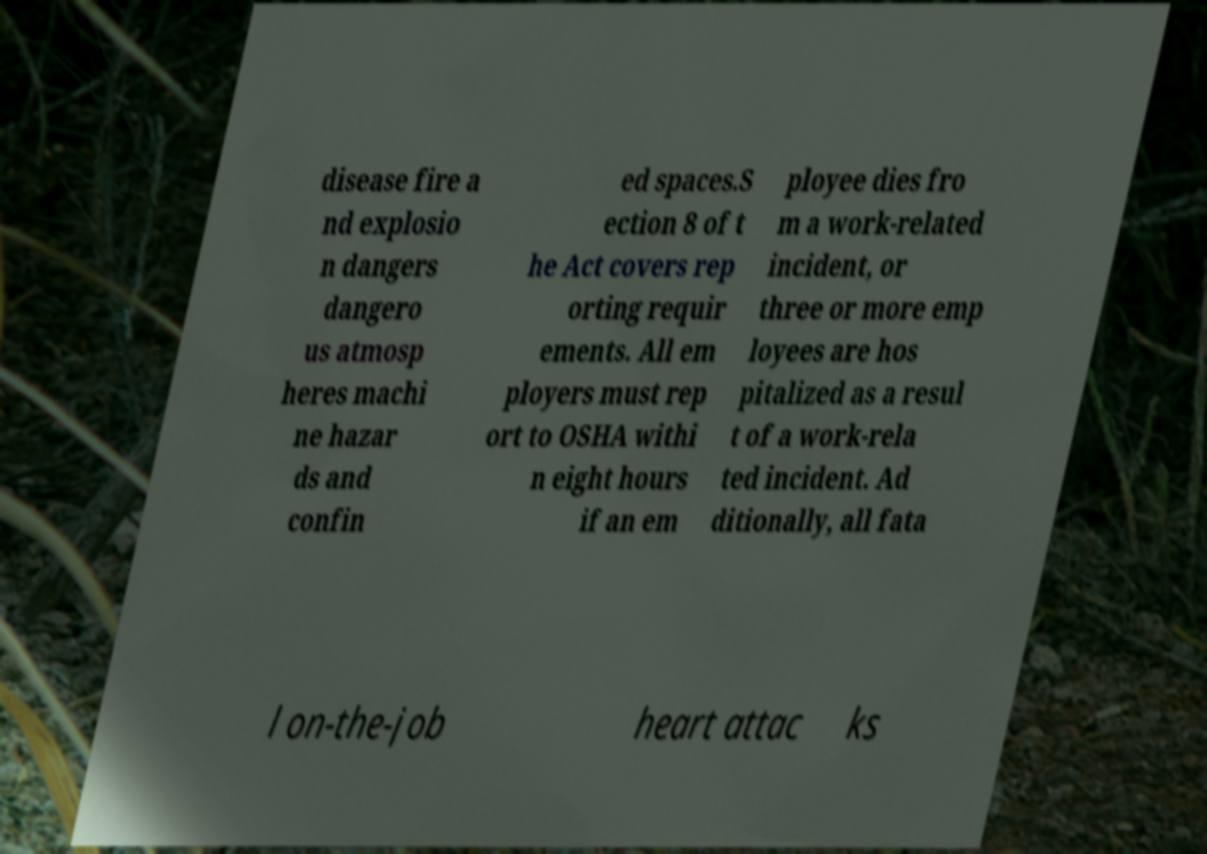Can you accurately transcribe the text from the provided image for me? disease fire a nd explosio n dangers dangero us atmosp heres machi ne hazar ds and confin ed spaces.S ection 8 of t he Act covers rep orting requir ements. All em ployers must rep ort to OSHA withi n eight hours if an em ployee dies fro m a work-related incident, or three or more emp loyees are hos pitalized as a resul t of a work-rela ted incident. Ad ditionally, all fata l on-the-job heart attac ks 